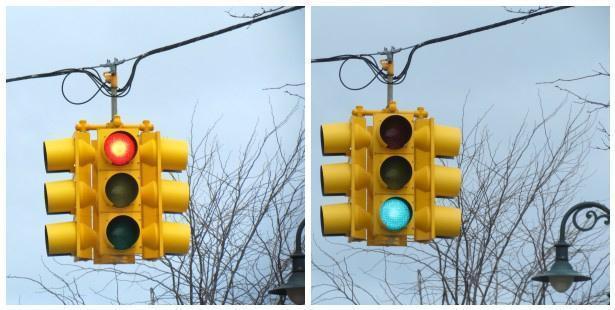How many traffic lights are there?
Give a very brief answer. 6. 